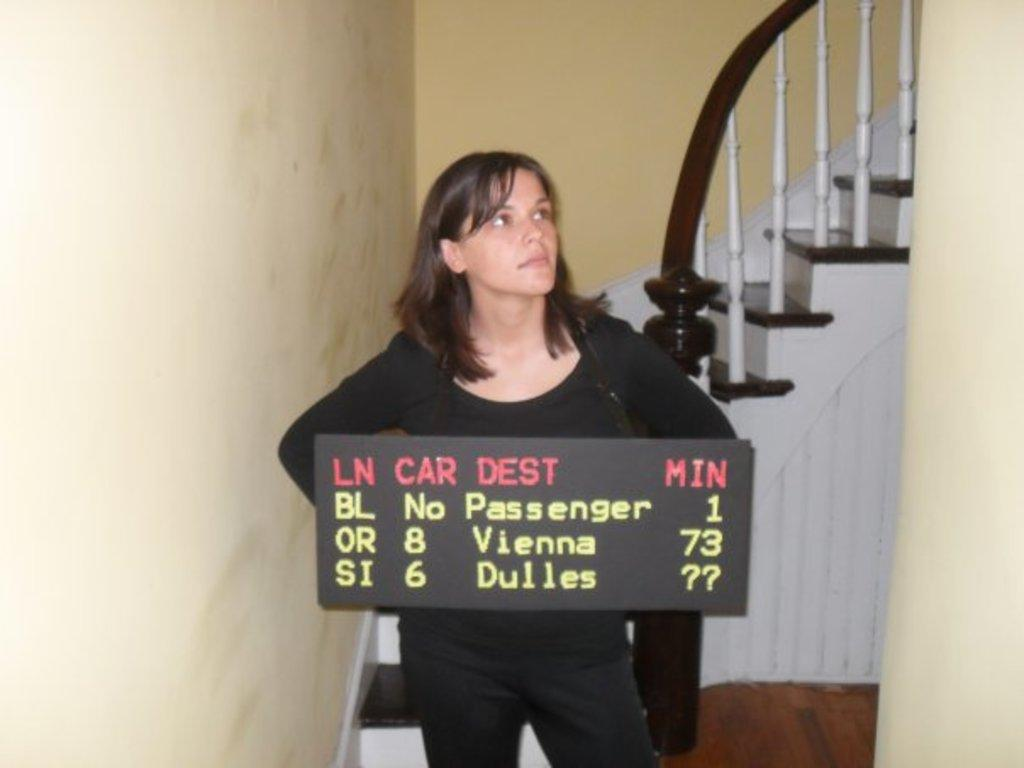Who is present in the image? There is a woman in the image. What is the woman holding in the image? The woman is holding a board with text. What architectural feature can be seen behind the woman? There is a staircase behind the woman. What type of structure is visible in the image? There is a wall in the image. What type of mitten is the woman wearing on her hand in the image? There is no mitten visible in the image; the woman is holding a board with text. Is there a band performing in the image? There is no band present in the image. 